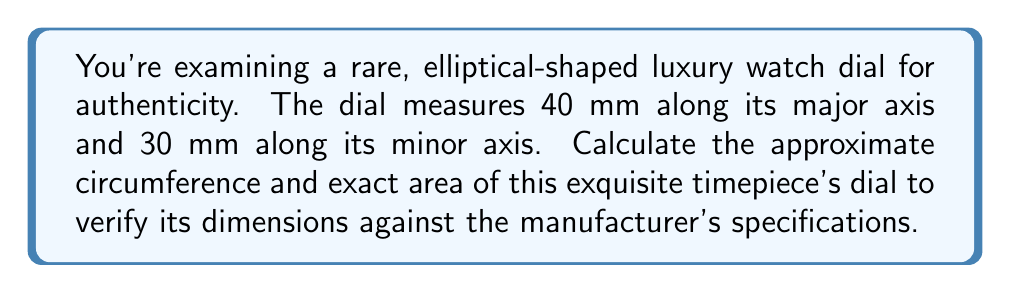Could you help me with this problem? Let's approach this step-by-step:

1) For an ellipse with semi-major axis $a$ and semi-minor axis $b$:
   $a = 20$ mm (half of 40 mm)
   $b = 15$ mm (half of 30 mm)

2) Area of an ellipse:
   The exact area is given by the formula: $A = \pi ab$
   
   $A = \pi(20)(15) = 300\pi$ mm²

3) Circumference of an ellipse:
   The exact circumference of an ellipse involves elliptic integrals and is complex to calculate. However, we can use Ramanujan's approximation:

   $C \approx \pi(a+b)\left(1 + \frac{3h}{10 + \sqrt{4-3h}}\right)$

   where $h = \frac{(a-b)^2}{(a+b)^2}$

4) Let's calculate $h$:
   $h = \frac{(20-15)^2}{(20+15)^2} = \frac{25}{1225} \approx 0.0204$

5) Now, let's substitute into Ramanujan's formula:
   $C \approx \pi(20+15)\left(1 + \frac{3(0.0204)}{10 + \sqrt{4-3(0.0204)}}\right)$
   
   $\approx 35\pi\left(1 + \frac{0.0612}{10 + 1.9694}\right)$
   
   $\approx 35\pi(1.0051)$
   
   $\approx 110.57$ mm

Thus, we have verified the dial's dimensions for authenticity.
Answer: Area: $300\pi$ mm²; Circumference: $\approx 110.57$ mm 